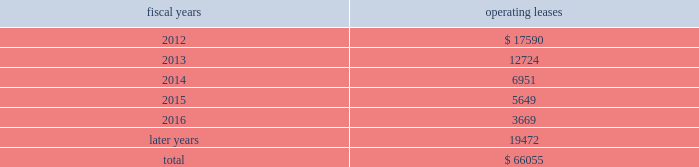The following is a schedule of future minimum rental payments required under long-term operating leases at october 29 , 2011 : fiscal years operating leases .
12 .
Commitments and contingencies from time to time in the ordinary course of the company 2019s business , various claims , charges and litigation are asserted or commenced against the company arising from , or related to , contractual matters , patents , trademarks , personal injury , environmental matters , product liability , insurance coverage and personnel and employment disputes .
As to such claims and litigation , the company can give no assurance that it will prevail .
The company does not believe that any current legal matters will have a material adverse effect on the company 2019s financial position , results of operations or cash flows .
13 .
Retirement plans the company and its subsidiaries have various savings and retirement plans covering substantially all employees .
The company maintains a defined contribution plan for the benefit of its eligible u.s .
Employees .
This plan provides for company contributions of up to 5% ( 5 % ) of each participant 2019s total eligible compensation .
In addition , the company contributes an amount equal to each participant 2019s pre-tax contribution , if any , up to a maximum of 3% ( 3 % ) of each participant 2019s total eligible compensation .
The total expense related to the defined contribution plan for u.s .
Employees was $ 21.9 million in fiscal 2011 , $ 20.5 million in fiscal 2010 and $ 21.5 million in fiscal 2009 .
The company also has various defined benefit pension and other retirement plans for certain non-u.s .
Employees that are consistent with local statutory requirements and practices .
The total expense related to the various defined benefit pension and other retirement plans for certain non-u.s .
Employees was $ 21.4 million in fiscal 2011 , $ 11.7 million in fiscal 2010 and $ 10.9 million in fiscal 2009 .
Non-u.s .
Plan disclosures the company 2019s funding policy for its foreign defined benefit pension plans is consistent with the local requirements of each country .
The plans 2019 assets consist primarily of u.s .
And non-u.s .
Equity securities , bonds , property and cash .
The benefit obligations and related assets under these plans have been measured at october 29 , 2011 and october 30 , 2010 .
Analog devices , inc .
Notes to consolidated financial statements 2014 ( continued ) .
What was the difference in percentage that total expenses changed between the us and non-us employees from 2009 to 2011? 
Rationale: to find the answer one must find the percentage increase for each the us and non-us . then compare these two numbers to find the difference in changes for the years .
Computations: (((21.4 - 10.9) / 10.9) - ((21.9 - 21.5) / 21.5))
Answer: 0.9447. 